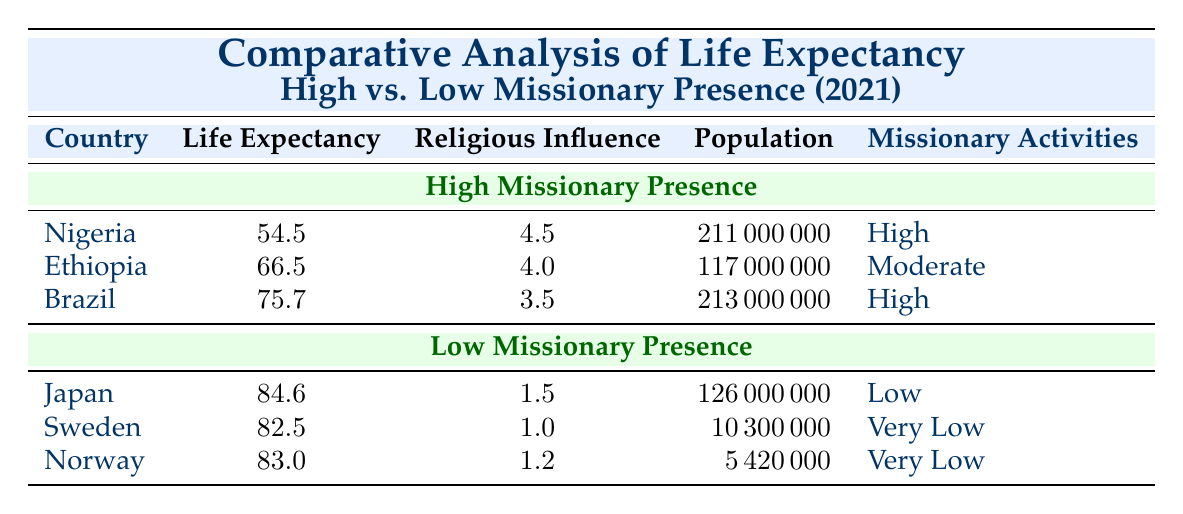What is the life expectancy of Ethiopia? The table shows that Ethiopia has a life expectancy of 66.5 years in 2021.
Answer: 66.5 Which country has the highest life expectancy in low missionary presence? According to the table, Japan has the highest life expectancy among low missionary presence countries, with a value of 84.6 years.
Answer: Japan What is the average life expectancy for countries with high missionary presence? The life expectancies for high missionary presence countries are 54.5 (Nigeria), 66.5 (Ethiopia), and 75.7 (Brazil). Summing these values gives 54.5 + 66.5 + 75.7 = 196.7. To find the average, divide by the number of countries (3): 196.7 / 3 = 65.57.
Answer: 65.57 Does Brazil have a higher life expectancy than Sweden? From the table, Brazil's life expectancy is 75.7 years while Sweden's is 82.5 years. Therefore, Brazil does not have a higher life expectancy than Sweden.
Answer: No Calculate the difference in life expectancy between Norway and Nigeria. Norway has a life expectancy of 83.0 years while Nigeria has 54.5 years. The difference is calculated as 83.0 - 54.5 = 28.5.
Answer: 28.5 Is the population of Ethiopia greater than that of Sweden? Ethiopia has a population of 117,000,000 while Sweden has a population of 10,300,000. Since 117 million is greater than 10.3 million, the statement is true.
Answer: Yes Which country has the lowest religious influence rating among high missionary presence countries? The country with the lowest religious influence rating in this category is Brazil, with a rating of 3.5, compared to Nigeria's 4.5 and Ethiopia's 4.0.
Answer: Brazil How many countries listed have a life expectancy of over 80 years? From the table, Japan (84.6), Sweden (82.5), and Norway (83.0) all have life expectancies over 80 years, making a total of 3 countries.
Answer: 3 Which country has the highest population among those with low missionary presence? Japan has the highest population among the low missionary presence countries listed, with 126,000,000 people.
Answer: Japan 